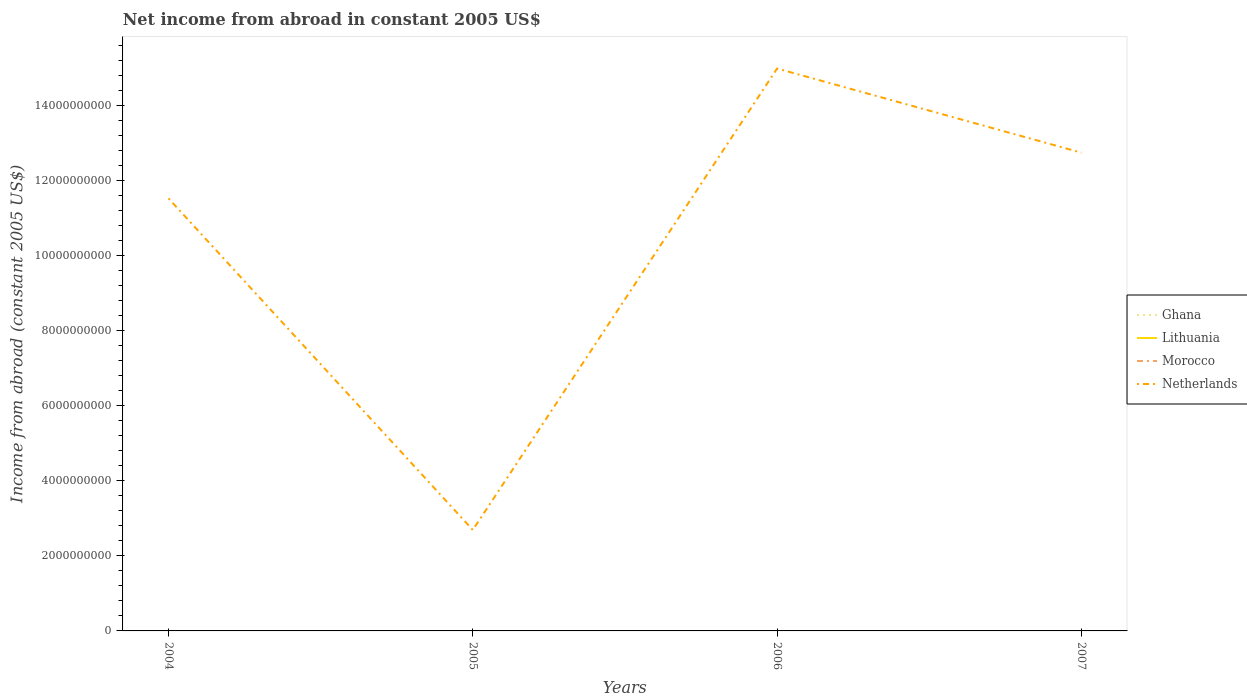How many different coloured lines are there?
Provide a short and direct response. 1. Does the line corresponding to Ghana intersect with the line corresponding to Lithuania?
Provide a short and direct response. No. Across all years, what is the maximum net income from abroad in Ghana?
Provide a short and direct response. 0. What is the total net income from abroad in Netherlands in the graph?
Make the answer very short. -1.22e+09. What is the difference between the highest and the second highest net income from abroad in Netherlands?
Your answer should be very brief. 1.23e+1. Is the net income from abroad in Morocco strictly greater than the net income from abroad in Lithuania over the years?
Provide a short and direct response. No. How many lines are there?
Offer a very short reply. 1. How many years are there in the graph?
Provide a short and direct response. 4. What is the difference between two consecutive major ticks on the Y-axis?
Make the answer very short. 2.00e+09. Are the values on the major ticks of Y-axis written in scientific E-notation?
Your answer should be compact. No. How many legend labels are there?
Give a very brief answer. 4. How are the legend labels stacked?
Provide a succinct answer. Vertical. What is the title of the graph?
Make the answer very short. Net income from abroad in constant 2005 US$. Does "Namibia" appear as one of the legend labels in the graph?
Provide a short and direct response. No. What is the label or title of the X-axis?
Provide a succinct answer. Years. What is the label or title of the Y-axis?
Provide a short and direct response. Income from abroad (constant 2005 US$). What is the Income from abroad (constant 2005 US$) of Ghana in 2004?
Your response must be concise. 0. What is the Income from abroad (constant 2005 US$) of Morocco in 2004?
Keep it short and to the point. 0. What is the Income from abroad (constant 2005 US$) in Netherlands in 2004?
Your response must be concise. 1.15e+1. What is the Income from abroad (constant 2005 US$) in Netherlands in 2005?
Give a very brief answer. 2.69e+09. What is the Income from abroad (constant 2005 US$) in Lithuania in 2006?
Give a very brief answer. 0. What is the Income from abroad (constant 2005 US$) in Morocco in 2006?
Offer a terse response. 0. What is the Income from abroad (constant 2005 US$) of Netherlands in 2006?
Give a very brief answer. 1.50e+1. What is the Income from abroad (constant 2005 US$) of Ghana in 2007?
Keep it short and to the point. 0. What is the Income from abroad (constant 2005 US$) of Lithuania in 2007?
Your response must be concise. 0. What is the Income from abroad (constant 2005 US$) of Morocco in 2007?
Your response must be concise. 0. What is the Income from abroad (constant 2005 US$) of Netherlands in 2007?
Ensure brevity in your answer.  1.27e+1. Across all years, what is the maximum Income from abroad (constant 2005 US$) of Netherlands?
Your response must be concise. 1.50e+1. Across all years, what is the minimum Income from abroad (constant 2005 US$) in Netherlands?
Provide a short and direct response. 2.69e+09. What is the total Income from abroad (constant 2005 US$) of Ghana in the graph?
Keep it short and to the point. 0. What is the total Income from abroad (constant 2005 US$) of Morocco in the graph?
Your answer should be very brief. 0. What is the total Income from abroad (constant 2005 US$) in Netherlands in the graph?
Your answer should be very brief. 4.19e+1. What is the difference between the Income from abroad (constant 2005 US$) in Netherlands in 2004 and that in 2005?
Give a very brief answer. 8.83e+09. What is the difference between the Income from abroad (constant 2005 US$) in Netherlands in 2004 and that in 2006?
Your answer should be compact. -3.46e+09. What is the difference between the Income from abroad (constant 2005 US$) in Netherlands in 2004 and that in 2007?
Your response must be concise. -1.22e+09. What is the difference between the Income from abroad (constant 2005 US$) in Netherlands in 2005 and that in 2006?
Offer a very short reply. -1.23e+1. What is the difference between the Income from abroad (constant 2005 US$) of Netherlands in 2005 and that in 2007?
Give a very brief answer. -1.00e+1. What is the difference between the Income from abroad (constant 2005 US$) in Netherlands in 2006 and that in 2007?
Offer a very short reply. 2.24e+09. What is the average Income from abroad (constant 2005 US$) in Morocco per year?
Your response must be concise. 0. What is the average Income from abroad (constant 2005 US$) of Netherlands per year?
Ensure brevity in your answer.  1.05e+1. What is the ratio of the Income from abroad (constant 2005 US$) of Netherlands in 2004 to that in 2005?
Your response must be concise. 4.28. What is the ratio of the Income from abroad (constant 2005 US$) in Netherlands in 2004 to that in 2006?
Provide a succinct answer. 0.77. What is the ratio of the Income from abroad (constant 2005 US$) of Netherlands in 2004 to that in 2007?
Your answer should be very brief. 0.9. What is the ratio of the Income from abroad (constant 2005 US$) in Netherlands in 2005 to that in 2006?
Ensure brevity in your answer.  0.18. What is the ratio of the Income from abroad (constant 2005 US$) of Netherlands in 2005 to that in 2007?
Provide a short and direct response. 0.21. What is the ratio of the Income from abroad (constant 2005 US$) in Netherlands in 2006 to that in 2007?
Keep it short and to the point. 1.18. What is the difference between the highest and the second highest Income from abroad (constant 2005 US$) in Netherlands?
Your answer should be very brief. 2.24e+09. What is the difference between the highest and the lowest Income from abroad (constant 2005 US$) of Netherlands?
Keep it short and to the point. 1.23e+1. 